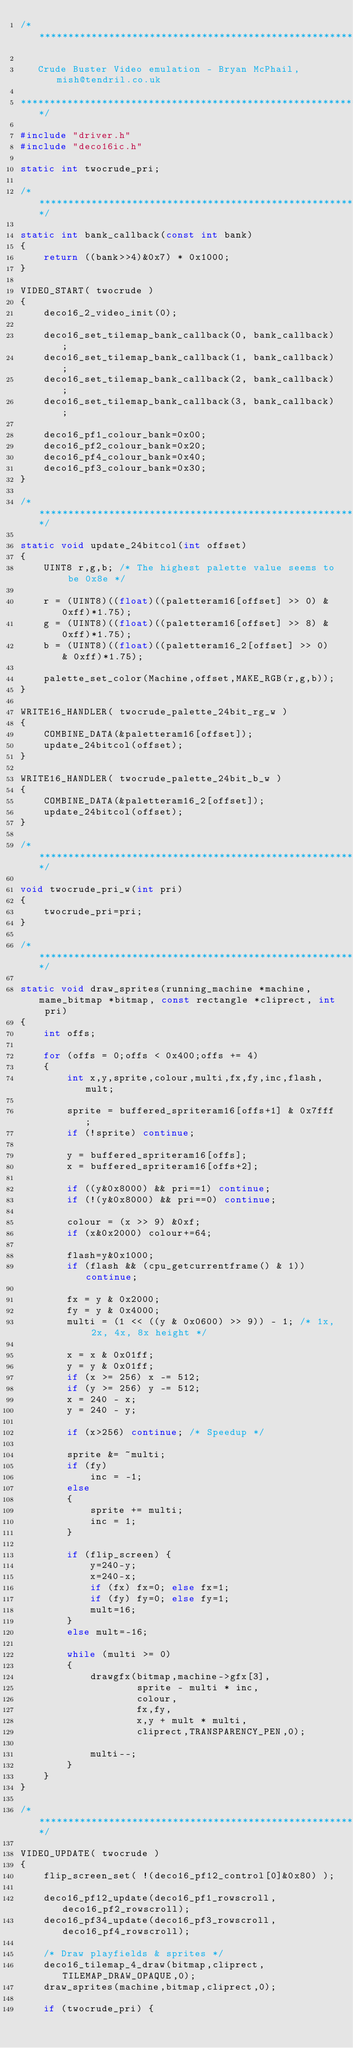<code> <loc_0><loc_0><loc_500><loc_500><_C_>/***************************************************************************

   Crude Buster Video emulation - Bryan McPhail, mish@tendril.co.uk

***************************************************************************/

#include "driver.h"
#include "deco16ic.h"

static int twocrude_pri;

/******************************************************************************/

static int bank_callback(const int bank)
{
	return ((bank>>4)&0x7) * 0x1000;
}

VIDEO_START( twocrude )
{
	deco16_2_video_init(0);

	deco16_set_tilemap_bank_callback(0, bank_callback);
	deco16_set_tilemap_bank_callback(1, bank_callback);
	deco16_set_tilemap_bank_callback(2, bank_callback);
	deco16_set_tilemap_bank_callback(3, bank_callback);

	deco16_pf1_colour_bank=0x00;
	deco16_pf2_colour_bank=0x20;
	deco16_pf4_colour_bank=0x40;
	deco16_pf3_colour_bank=0x30;
}

/******************************************************************************/

static void update_24bitcol(int offset)
{
	UINT8 r,g,b; /* The highest palette value seems to be 0x8e */

	r = (UINT8)((float)((paletteram16[offset] >> 0) & 0xff)*1.75);
	g = (UINT8)((float)((paletteram16[offset] >> 8) & 0xff)*1.75);
	b = (UINT8)((float)((paletteram16_2[offset] >> 0) & 0xff)*1.75);

	palette_set_color(Machine,offset,MAKE_RGB(r,g,b));
}

WRITE16_HANDLER( twocrude_palette_24bit_rg_w )
{
	COMBINE_DATA(&paletteram16[offset]);
	update_24bitcol(offset);
}

WRITE16_HANDLER( twocrude_palette_24bit_b_w )
{
	COMBINE_DATA(&paletteram16_2[offset]);
	update_24bitcol(offset);
}

/******************************************************************************/

void twocrude_pri_w(int pri)
{
	twocrude_pri=pri;
}

/******************************************************************************/

static void draw_sprites(running_machine *machine, mame_bitmap *bitmap, const rectangle *cliprect, int pri)
{
	int offs;

	for (offs = 0;offs < 0x400;offs += 4)
	{
		int x,y,sprite,colour,multi,fx,fy,inc,flash,mult;

		sprite = buffered_spriteram16[offs+1] & 0x7fff;
		if (!sprite) continue;

		y = buffered_spriteram16[offs];
		x = buffered_spriteram16[offs+2];

		if ((y&0x8000) && pri==1) continue;
		if (!(y&0x8000) && pri==0) continue;

		colour = (x >> 9) &0xf;
		if (x&0x2000) colour+=64;

		flash=y&0x1000;
		if (flash && (cpu_getcurrentframe() & 1)) continue;

		fx = y & 0x2000;
		fy = y & 0x4000;
		multi = (1 << ((y & 0x0600) >> 9)) - 1;	/* 1x, 2x, 4x, 8x height */

		x = x & 0x01ff;
		y = y & 0x01ff;
		if (x >= 256) x -= 512;
		if (y >= 256) y -= 512;
		x = 240 - x;
		y = 240 - y;

		if (x>256) continue; /* Speedup */

		sprite &= ~multi;
		if (fy)
			inc = -1;
		else
		{
			sprite += multi;
			inc = 1;
		}

		if (flip_screen) {
			y=240-y;
			x=240-x;
			if (fx) fx=0; else fx=1;
			if (fy) fy=0; else fy=1;
			mult=16;
		}
		else mult=-16;

		while (multi >= 0)
		{
			drawgfx(bitmap,machine->gfx[3],
					sprite - multi * inc,
					colour,
					fx,fy,
					x,y + mult * multi,
					cliprect,TRANSPARENCY_PEN,0);

			multi--;
		}
	}
}

/******************************************************************************/

VIDEO_UPDATE( twocrude )
{
	flip_screen_set( !(deco16_pf12_control[0]&0x80) );

	deco16_pf12_update(deco16_pf1_rowscroll,deco16_pf2_rowscroll);
	deco16_pf34_update(deco16_pf3_rowscroll,deco16_pf4_rowscroll);

	/* Draw playfields & sprites */
	deco16_tilemap_4_draw(bitmap,cliprect,TILEMAP_DRAW_OPAQUE,0);
	draw_sprites(machine,bitmap,cliprect,0);

	if (twocrude_pri) {</code> 